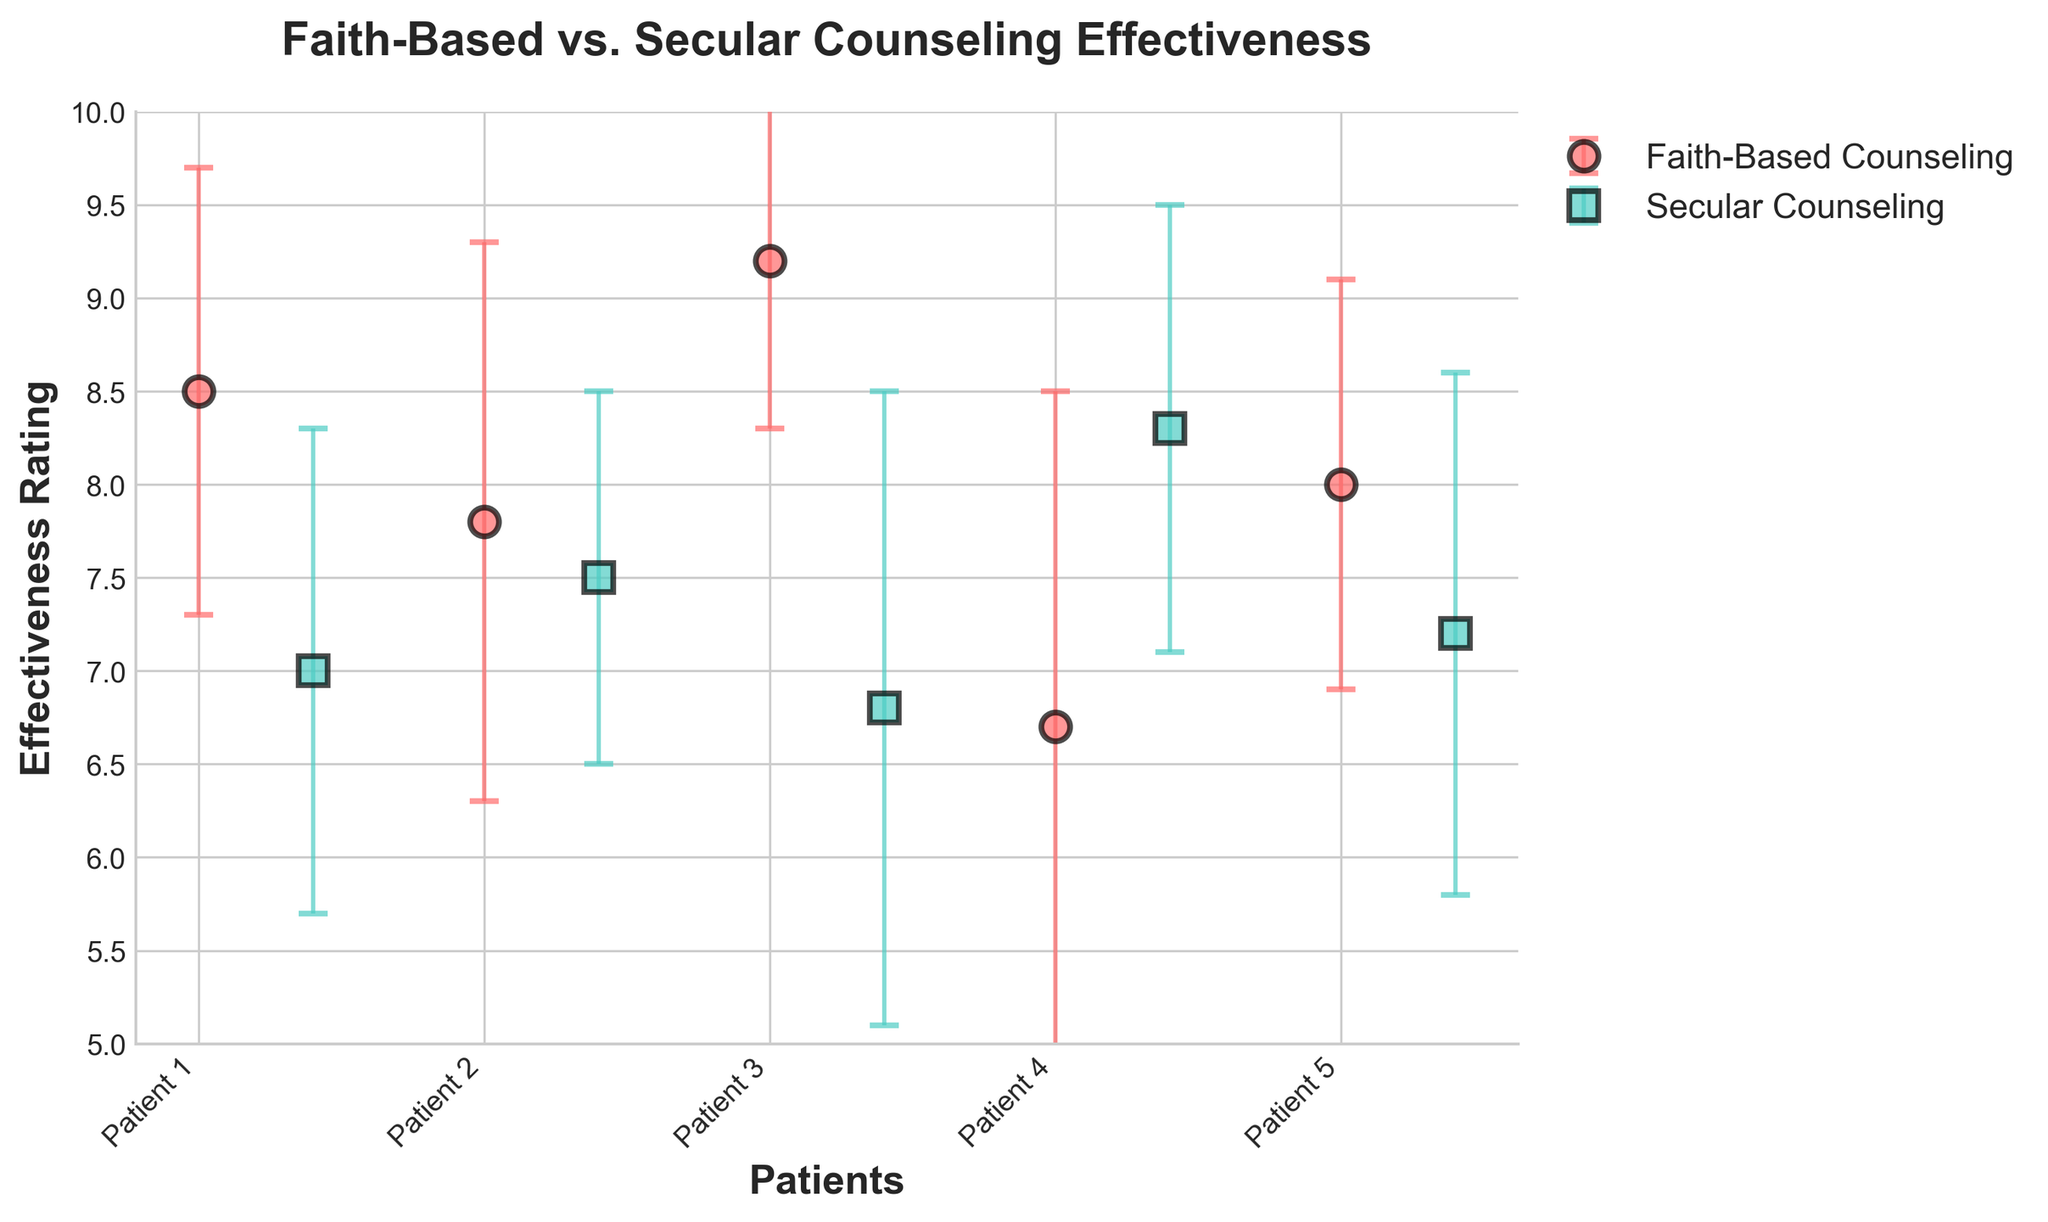What's the title of the figure? The title of the figure is positioned at the top center of the plot.
Answer: Faith-Based vs. Secular Counseling Effectiveness What's the range of the effectiveness rating on the y-axis? The y-axis represents the effectiveness rating and shows labels from 5 to 10.
Answer: 5 to 10 How many patients are displayed for each counseling type? Each dot represents a patient, and there are distinct markers for the two types of counseling. Counting the markers, each type has 5 patients.
Answer: 5 Which counseling type has the highest effectiveness rating, and what is that rating? The highest point for Faith-Based Counseling is 9.2, as indicated by the third marker, while the highest for Secular Counseling is 8.3, as indicated by the fourth marker.
Answer: Faith-Based Counseling, 9.2 Which patient has the highest outcome variability, and what is its value? Outcome variability is represented by the length of the error bars. The longest error bar belongs to Faith-Based Counseling patient 4 with a value of 1.8.
Answer: Patient 4, 1.8 What is the average effectiveness rating for Faith-Based Counseling? The effectiveness ratings for Faith-Based Counseling are 8.5, 7.8, 9.2, 6.7, and 8.0. Sum these values and divide by 5: (8.5 + 7.8 + 9.2 + 6.7 + 8.0) / 5 = 8.04
Answer: 8.04 Which counseling type has the lower mean outcome variability, and what is that value? Calculate the average of the outcome variability for each type. Faith-Based Counseling: (1.2 + 1.5 + 0.9 + 1.8 + 1.1) / 5 = 1.3. Secular Counseling: (1.3 + 1.0 + 1.7 + 1.2 + 1.4) / 5 = 1.32. Faith-Based has the lower average with 1.3.
Answer: Faith-Based Counseling, 1.3 How does the variability in effectiveness ratings compare between the two types of counseling? Evaluate the length of error bars. Faith-Based Counseling shows a wider range in some cases, such as for Patient 4, while Secular Counseling has relatively consistent error bar lengths but a slightly higher average variability. Overall, Faith-Based has both the highest and lowest variability values.
Answer: Faith-Based Counseling has more variable outcome variability Which patient has the smallest effectiveness rating in each counseling type, and what are these ratings? The lowest effectiveness rating for Faith-Based Counseling is 6.7 from Patient 4, and for Secular Counseling is 6.8 from Patient 8.
Answer: Patient 4, 6.7 (Faith-Based); Patient 8, 6.8 (Secular) What pattern can you observe in the effectiveness ratings between the two counseling types? Faith-Based Counseling generally tends to have higher effectiveness ratings, with data points primarily above 7. Secular Counseling has a wider spread with some ratings as low as 6.8 but none as high as the top rating for Faith-Based.
Answer: Faith-Based typically has higher ratings 